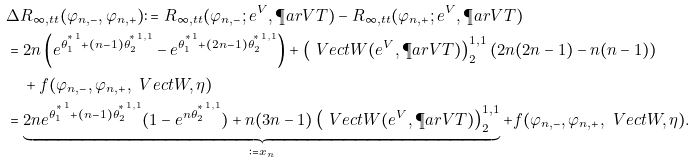Convert formula to latex. <formula><loc_0><loc_0><loc_500><loc_500>& \Delta R _ { \infty , \L t t } ( \varphi _ { n , - } , \varphi _ { n , + } ) \colon = R _ { \infty , \L t t } ( \varphi _ { n , - } ; e ^ { V } , \P a r V T ) - R _ { \infty , \L t t } ( \varphi _ { n , + } ; e ^ { V } , \P a r V T ) \\ & = 2 n \left ( e ^ { { \theta _ { 1 } ^ { ^ { * } } } ^ { 1 } + ( n - 1 ) { \theta _ { 2 } ^ { ^ { * } } } ^ { 1 , 1 } } - e ^ { { \theta _ { 1 } ^ { ^ { * } } } ^ { 1 } + ( 2 n - 1 ) { \theta _ { 2 } ^ { ^ { * } } } ^ { 1 , 1 } } \right ) + \left ( \ V e c t { W } ( e ^ { V } , \P a r V T ) \right ) _ { 2 } ^ { 1 , 1 } \left ( 2 n ( 2 n - 1 ) - n ( n - 1 ) \right ) \\ & \quad + f ( \varphi _ { n , - } , \varphi _ { n , + } , \ V e c t { W } , \eta ) \\ & = \underbrace { 2 n e ^ { { \theta _ { 1 } ^ { ^ { * } } } ^ { 1 } + ( n - 1 ) { \theta _ { 2 } ^ { ^ { * } } } ^ { 1 , 1 } } ( 1 - e ^ { { n \theta _ { 2 } ^ { ^ { * } } } ^ { 1 , 1 } } ) + n ( 3 n - 1 ) \left ( \ V e c t { W } ( e ^ { V } , \P a r V T ) \right ) _ { 2 } ^ { 1 , 1 } } _ { \colon = x _ { n } } + f ( \varphi _ { n , - } , \varphi _ { n , + } , \ V e c t { W } , \eta ) .</formula> 